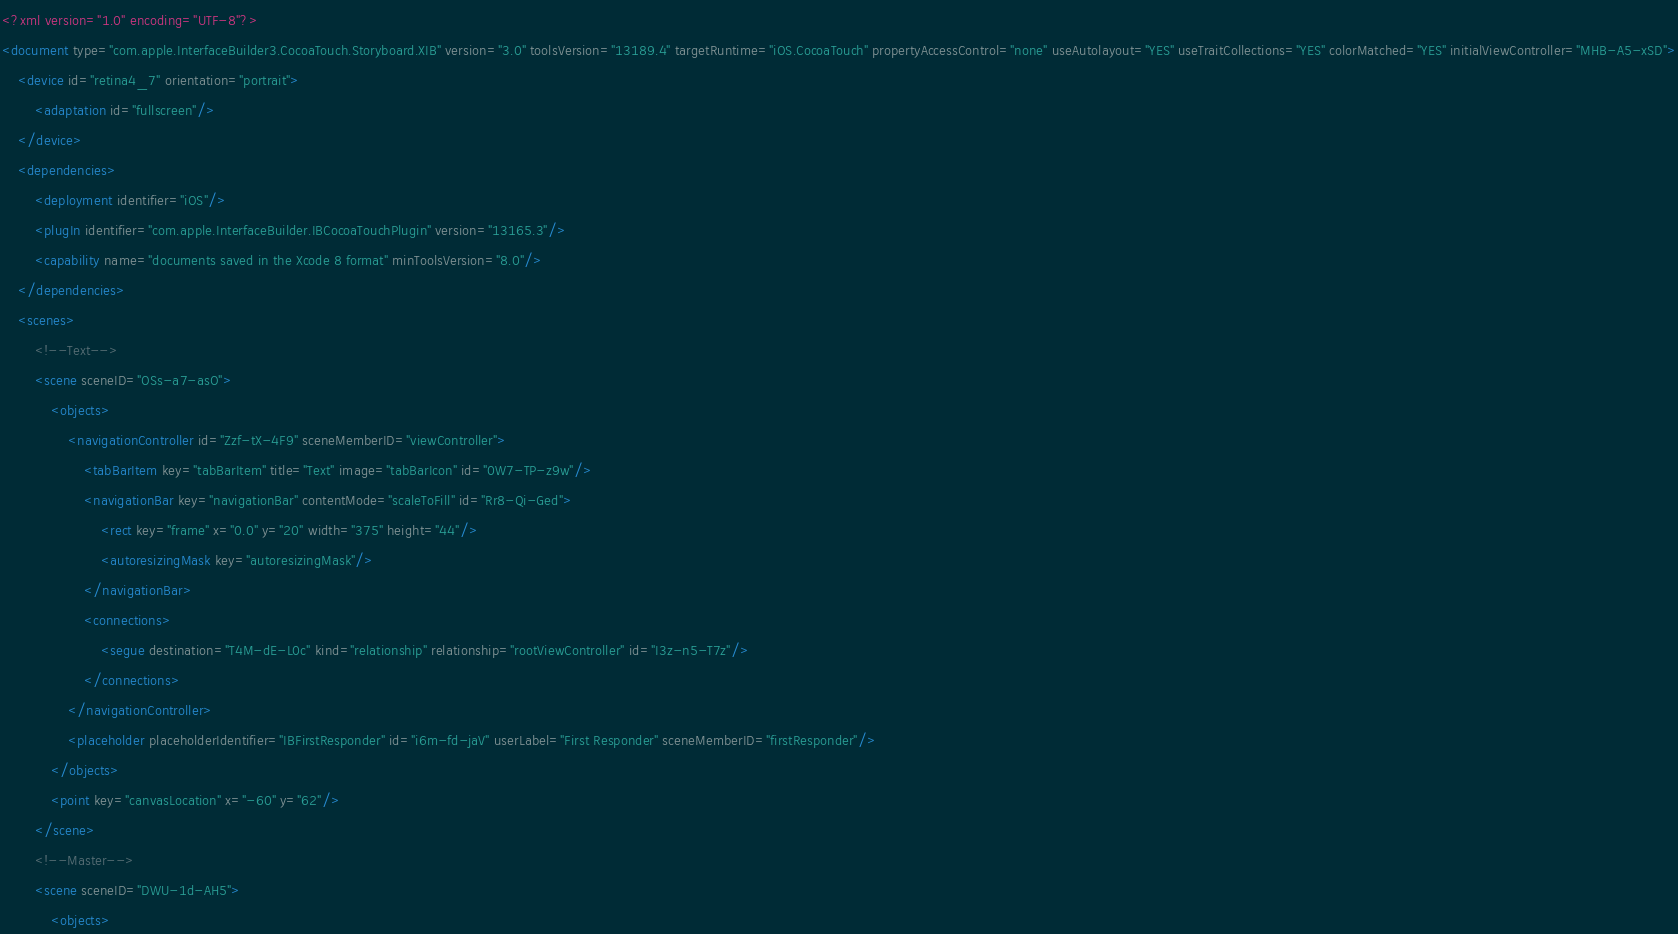Convert code to text. <code><loc_0><loc_0><loc_500><loc_500><_XML_><?xml version="1.0" encoding="UTF-8"?>
<document type="com.apple.InterfaceBuilder3.CocoaTouch.Storyboard.XIB" version="3.0" toolsVersion="13189.4" targetRuntime="iOS.CocoaTouch" propertyAccessControl="none" useAutolayout="YES" useTraitCollections="YES" colorMatched="YES" initialViewController="MHB-A5-xSD">
    <device id="retina4_7" orientation="portrait">
        <adaptation id="fullscreen"/>
    </device>
    <dependencies>
        <deployment identifier="iOS"/>
        <plugIn identifier="com.apple.InterfaceBuilder.IBCocoaTouchPlugin" version="13165.3"/>
        <capability name="documents saved in the Xcode 8 format" minToolsVersion="8.0"/>
    </dependencies>
    <scenes>
        <!--Text-->
        <scene sceneID="OSs-a7-asO">
            <objects>
                <navigationController id="Zzf-tX-4F9" sceneMemberID="viewController">
                    <tabBarItem key="tabBarItem" title="Text" image="tabBarIcon" id="0W7-TP-z9w"/>
                    <navigationBar key="navigationBar" contentMode="scaleToFill" id="Rr8-Qi-Ged">
                        <rect key="frame" x="0.0" y="20" width="375" height="44"/>
                        <autoresizingMask key="autoresizingMask"/>
                    </navigationBar>
                    <connections>
                        <segue destination="T4M-dE-L0c" kind="relationship" relationship="rootViewController" id="I3z-n5-T7z"/>
                    </connections>
                </navigationController>
                <placeholder placeholderIdentifier="IBFirstResponder" id="i6m-fd-jaV" userLabel="First Responder" sceneMemberID="firstResponder"/>
            </objects>
            <point key="canvasLocation" x="-60" y="62"/>
        </scene>
        <!--Master-->
        <scene sceneID="DWU-1d-AH5">
            <objects></code> 